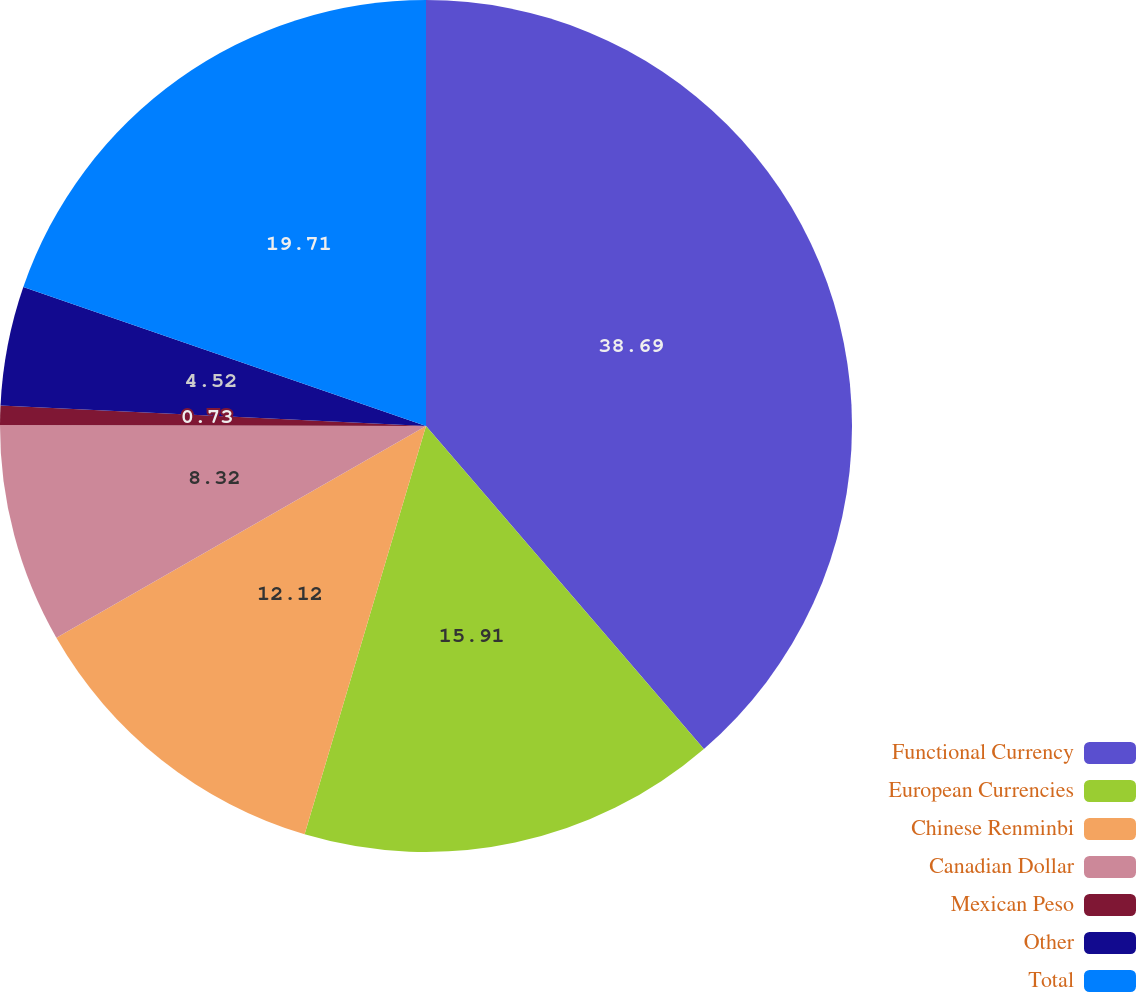Convert chart. <chart><loc_0><loc_0><loc_500><loc_500><pie_chart><fcel>Functional Currency<fcel>European Currencies<fcel>Chinese Renminbi<fcel>Canadian Dollar<fcel>Mexican Peso<fcel>Other<fcel>Total<nl><fcel>38.69%<fcel>15.91%<fcel>12.12%<fcel>8.32%<fcel>0.73%<fcel>4.52%<fcel>19.71%<nl></chart> 